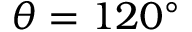Convert formula to latex. <formula><loc_0><loc_0><loc_500><loc_500>\theta = 1 2 0 ^ { \circ }</formula> 